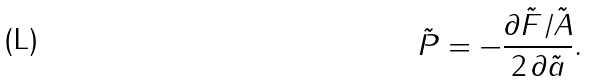Convert formula to latex. <formula><loc_0><loc_0><loc_500><loc_500>\tilde { P } = - \frac { \partial \tilde { F } / \tilde { A } } { 2 \, \partial \tilde { a } } .</formula> 